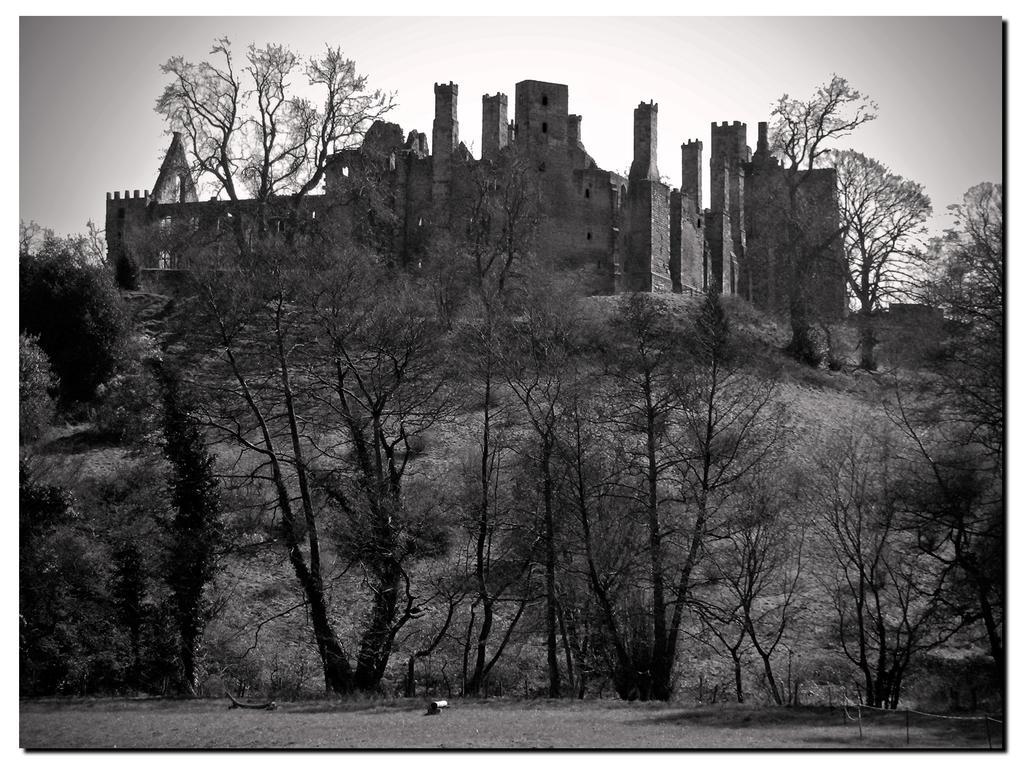Could you give a brief overview of what you see in this image? In the picture we can see some trees and behind it, we can see a hill and on the top of it, we can see an old house and near it also we can see some trees and in the background we can see the sky. 